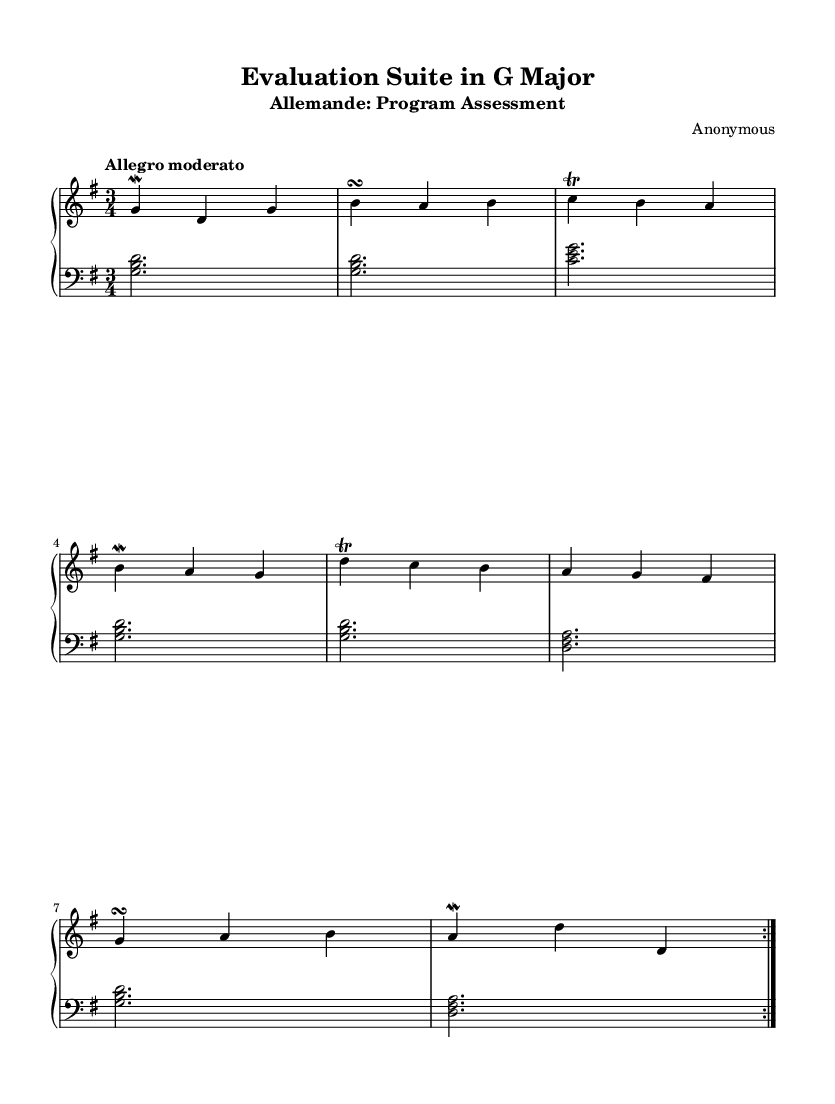What is the key signature of this music? The key signature is indicated by the presence of one sharp, which corresponds to F#, marking the piece as G major.
Answer: G major What is the time signature of this music? The time signature is found at the beginning of the piece and is represented as a fraction, specifically 3 over 4, indicating it is a triple meter.
Answer: 3/4 What is the tempo marking for this piece? The tempo marking is noted at the beginning of the score and reads "Allegro moderato," which suggests a moderately fast tempo.
Answer: Allegro moderato How many times is the main theme repeated? The main theme, shown in the upper part of the score, is marked with "volta 2," indicating it is repeated twice.
Answer: 2 What is the name of the first movement? The subtitle of the piece provides this information, indicating that the first movement is titled "Program Assessment."
Answer: Program Assessment How many voices are there in the score? The score shows two distinct staves labeled as upper and lower, indicating there are two voices, typically representing the right and left hands in keyboard music.
Answer: 2 